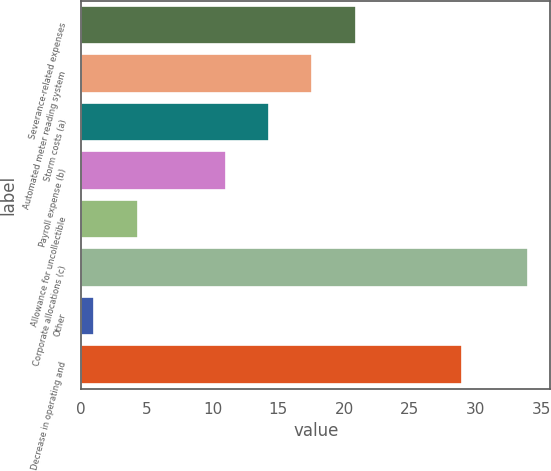Convert chart to OTSL. <chart><loc_0><loc_0><loc_500><loc_500><bar_chart><fcel>Severance-related expenses<fcel>Automated meter reading system<fcel>Storm costs (a)<fcel>Payroll expense (b)<fcel>Allowance for uncollectible<fcel>Corporate allocations (c)<fcel>Other<fcel>Decrease in operating and<nl><fcel>20.9<fcel>17.6<fcel>14.3<fcel>11<fcel>4.3<fcel>34<fcel>1<fcel>29<nl></chart> 